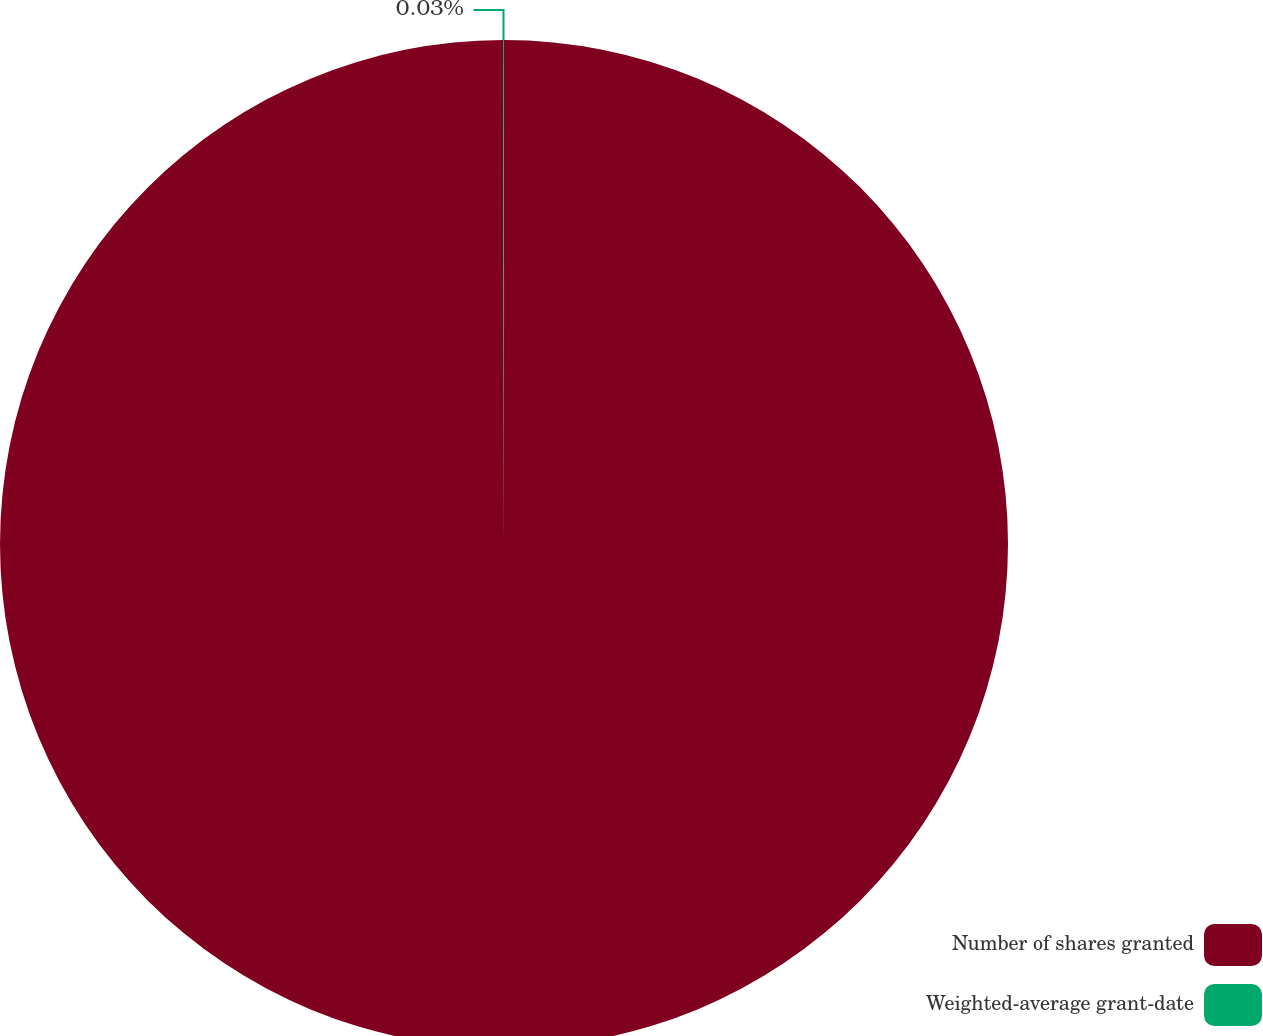Convert chart to OTSL. <chart><loc_0><loc_0><loc_500><loc_500><pie_chart><fcel>Number of shares granted<fcel>Weighted-average grant-date<nl><fcel>99.97%<fcel>0.03%<nl></chart> 